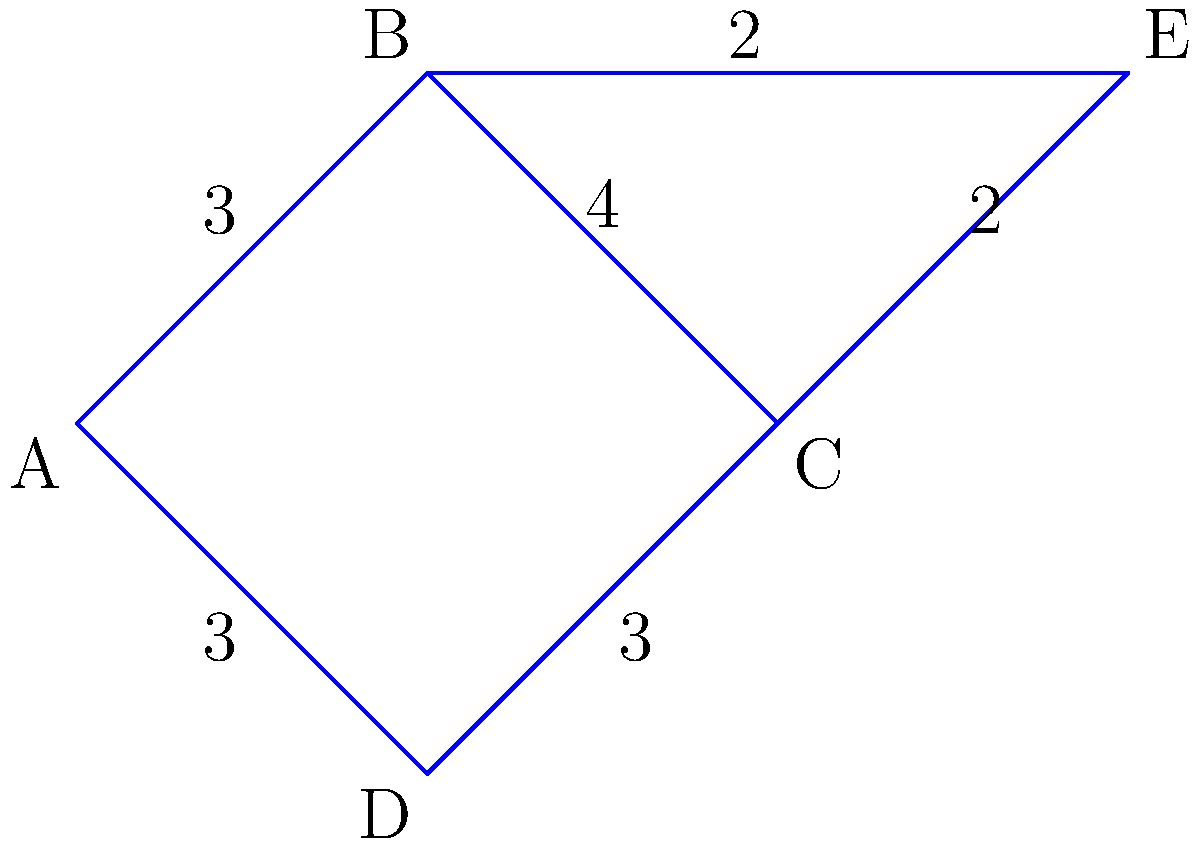As an urban planning officer, you're tasked with optimizing the road network in a new development. The graph represents intersections (nodes) and roads (edges) with their lengths in kilometers. What is the total length of the minimum spanning tree that connects all intersections while minimizing the total road length? To find the minimum spanning tree, we'll use Kruskal's algorithm:

1. Sort all edges by weight (length):
   BE = 2, CE = 2, AB = 3, AD = 3, CD = 3, BC = 4

2. Start with an empty set and add edges in order of increasing weight:
   a. Add BE (2km)
   b. Add CE (2km)
   c. Add AB (3km)
   d. Add CD (3km)

3. Stop when all vertices are connected (5 vertices, 4 edges needed).

4. Calculate the total length:
   $$ \text{Total Length} = BE + CE + AB + CD $$
   $$ = 2 + 2 + 3 + 3 = 10 \text{ km} $$

The minimum spanning tree includes edges BE, CE, AB, and CD, with a total length of 10 km.
Answer: 10 km 